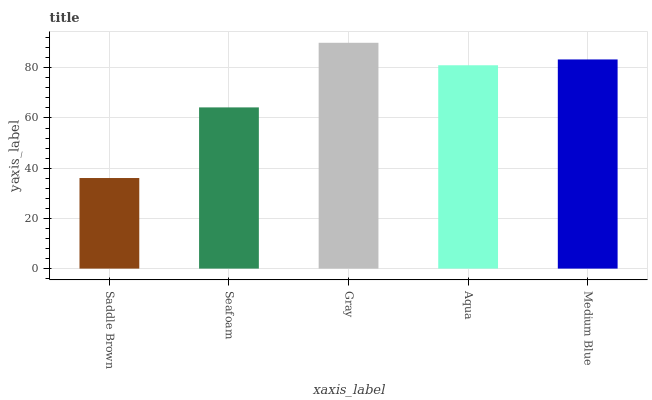Is Saddle Brown the minimum?
Answer yes or no. Yes. Is Gray the maximum?
Answer yes or no. Yes. Is Seafoam the minimum?
Answer yes or no. No. Is Seafoam the maximum?
Answer yes or no. No. Is Seafoam greater than Saddle Brown?
Answer yes or no. Yes. Is Saddle Brown less than Seafoam?
Answer yes or no. Yes. Is Saddle Brown greater than Seafoam?
Answer yes or no. No. Is Seafoam less than Saddle Brown?
Answer yes or no. No. Is Aqua the high median?
Answer yes or no. Yes. Is Aqua the low median?
Answer yes or no. Yes. Is Seafoam the high median?
Answer yes or no. No. Is Saddle Brown the low median?
Answer yes or no. No. 